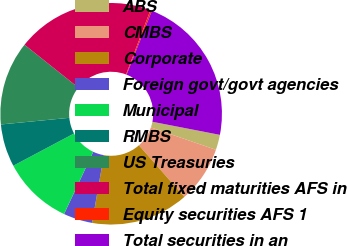Convert chart to OTSL. <chart><loc_0><loc_0><loc_500><loc_500><pie_chart><fcel>ABS<fcel>CMBS<fcel>Corporate<fcel>Foreign govt/govt agencies<fcel>Municipal<fcel>RMBS<fcel>US Treasuries<fcel>Total fixed maturities AFS in<fcel>Equity securities AFS 1<fcel>Total securities in an<nl><fcel>2.22%<fcel>8.24%<fcel>14.25%<fcel>4.23%<fcel>10.24%<fcel>6.23%<fcel>12.25%<fcel>20.06%<fcel>0.22%<fcel>22.06%<nl></chart> 